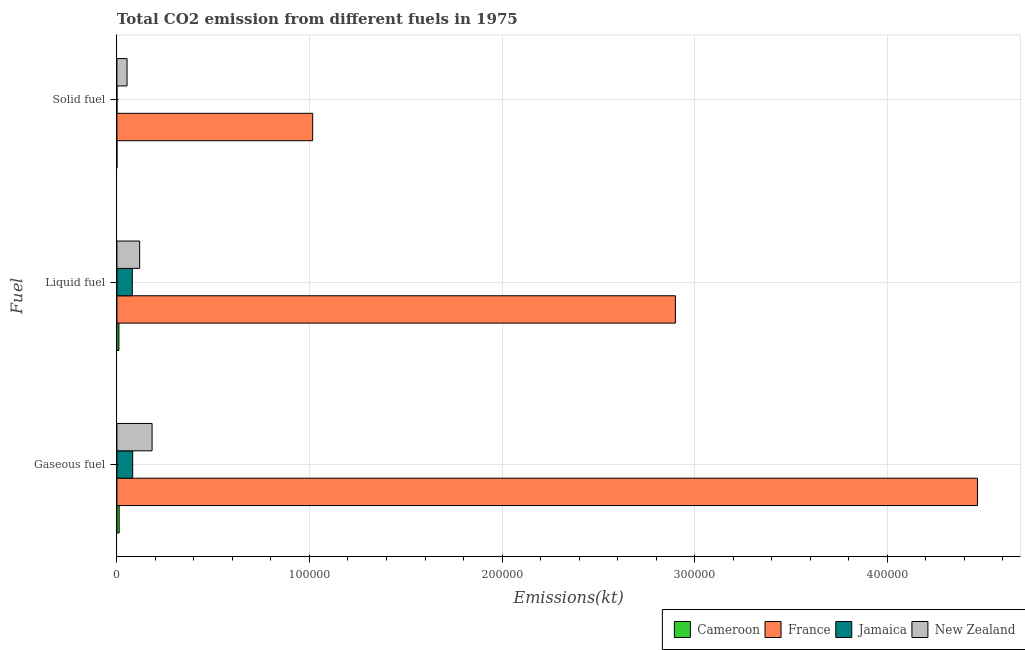How many different coloured bars are there?
Ensure brevity in your answer.  4. Are the number of bars per tick equal to the number of legend labels?
Make the answer very short. Yes. What is the label of the 1st group of bars from the top?
Keep it short and to the point. Solid fuel. What is the amount of co2 emissions from liquid fuel in Cameroon?
Offer a very short reply. 1041.43. Across all countries, what is the maximum amount of co2 emissions from liquid fuel?
Ensure brevity in your answer.  2.90e+05. Across all countries, what is the minimum amount of co2 emissions from solid fuel?
Keep it short and to the point. 3.67. In which country was the amount of co2 emissions from liquid fuel maximum?
Your answer should be compact. France. In which country was the amount of co2 emissions from solid fuel minimum?
Provide a succinct answer. Cameroon. What is the total amount of co2 emissions from liquid fuel in the graph?
Your answer should be very brief. 3.11e+05. What is the difference between the amount of co2 emissions from liquid fuel in Cameroon and that in France?
Keep it short and to the point. -2.89e+05. What is the difference between the amount of co2 emissions from gaseous fuel in Cameroon and the amount of co2 emissions from solid fuel in New Zealand?
Your answer should be very brief. -4092.37. What is the average amount of co2 emissions from gaseous fuel per country?
Offer a very short reply. 1.19e+05. What is the difference between the amount of co2 emissions from solid fuel and amount of co2 emissions from gaseous fuel in New Zealand?
Ensure brevity in your answer.  -1.30e+04. What is the ratio of the amount of co2 emissions from solid fuel in France to that in New Zealand?
Ensure brevity in your answer.  19.35. What is the difference between the highest and the second highest amount of co2 emissions from liquid fuel?
Provide a succinct answer. 2.78e+05. What is the difference between the highest and the lowest amount of co2 emissions from liquid fuel?
Give a very brief answer. 2.89e+05. In how many countries, is the amount of co2 emissions from gaseous fuel greater than the average amount of co2 emissions from gaseous fuel taken over all countries?
Your answer should be very brief. 1. Is the sum of the amount of co2 emissions from gaseous fuel in Cameroon and Jamaica greater than the maximum amount of co2 emissions from solid fuel across all countries?
Give a very brief answer. No. What does the 4th bar from the top in Liquid fuel represents?
Offer a terse response. Cameroon. What does the 4th bar from the bottom in Liquid fuel represents?
Your response must be concise. New Zealand. Are all the bars in the graph horizontal?
Ensure brevity in your answer.  Yes. How many countries are there in the graph?
Give a very brief answer. 4. Are the values on the major ticks of X-axis written in scientific E-notation?
Make the answer very short. No. Does the graph contain any zero values?
Give a very brief answer. No. Where does the legend appear in the graph?
Offer a terse response. Bottom right. How many legend labels are there?
Provide a short and direct response. 4. How are the legend labels stacked?
Your answer should be very brief. Horizontal. What is the title of the graph?
Make the answer very short. Total CO2 emission from different fuels in 1975. Does "United Kingdom" appear as one of the legend labels in the graph?
Your answer should be compact. No. What is the label or title of the X-axis?
Provide a short and direct response. Emissions(kt). What is the label or title of the Y-axis?
Ensure brevity in your answer.  Fuel. What is the Emissions(kt) in Cameroon in Gaseous fuel?
Provide a short and direct response. 1162.44. What is the Emissions(kt) of France in Gaseous fuel?
Ensure brevity in your answer.  4.47e+05. What is the Emissions(kt) of Jamaica in Gaseous fuel?
Keep it short and to the point. 8188.41. What is the Emissions(kt) of New Zealand in Gaseous fuel?
Offer a very short reply. 1.83e+04. What is the Emissions(kt) in Cameroon in Liquid fuel?
Keep it short and to the point. 1041.43. What is the Emissions(kt) of France in Liquid fuel?
Provide a succinct answer. 2.90e+05. What is the Emissions(kt) in Jamaica in Liquid fuel?
Provide a succinct answer. 7983.06. What is the Emissions(kt) in New Zealand in Liquid fuel?
Your answer should be very brief. 1.18e+04. What is the Emissions(kt) of Cameroon in Solid fuel?
Your answer should be very brief. 3.67. What is the Emissions(kt) of France in Solid fuel?
Offer a terse response. 1.02e+05. What is the Emissions(kt) of Jamaica in Solid fuel?
Make the answer very short. 3.67. What is the Emissions(kt) of New Zealand in Solid fuel?
Your answer should be very brief. 5254.81. Across all Fuel, what is the maximum Emissions(kt) of Cameroon?
Provide a succinct answer. 1162.44. Across all Fuel, what is the maximum Emissions(kt) in France?
Ensure brevity in your answer.  4.47e+05. Across all Fuel, what is the maximum Emissions(kt) of Jamaica?
Offer a terse response. 8188.41. Across all Fuel, what is the maximum Emissions(kt) of New Zealand?
Provide a short and direct response. 1.83e+04. Across all Fuel, what is the minimum Emissions(kt) of Cameroon?
Make the answer very short. 3.67. Across all Fuel, what is the minimum Emissions(kt) of France?
Offer a terse response. 1.02e+05. Across all Fuel, what is the minimum Emissions(kt) in Jamaica?
Offer a very short reply. 3.67. Across all Fuel, what is the minimum Emissions(kt) in New Zealand?
Your answer should be compact. 5254.81. What is the total Emissions(kt) in Cameroon in the graph?
Your answer should be very brief. 2207.53. What is the total Emissions(kt) of France in the graph?
Keep it short and to the point. 8.39e+05. What is the total Emissions(kt) in Jamaica in the graph?
Provide a short and direct response. 1.62e+04. What is the total Emissions(kt) in New Zealand in the graph?
Ensure brevity in your answer.  3.53e+04. What is the difference between the Emissions(kt) of Cameroon in Gaseous fuel and that in Liquid fuel?
Your response must be concise. 121.01. What is the difference between the Emissions(kt) in France in Gaseous fuel and that in Liquid fuel?
Keep it short and to the point. 1.57e+05. What is the difference between the Emissions(kt) in Jamaica in Gaseous fuel and that in Liquid fuel?
Your response must be concise. 205.35. What is the difference between the Emissions(kt) of New Zealand in Gaseous fuel and that in Liquid fuel?
Offer a terse response. 6461.25. What is the difference between the Emissions(kt) in Cameroon in Gaseous fuel and that in Solid fuel?
Your response must be concise. 1158.77. What is the difference between the Emissions(kt) in France in Gaseous fuel and that in Solid fuel?
Keep it short and to the point. 3.45e+05. What is the difference between the Emissions(kt) in Jamaica in Gaseous fuel and that in Solid fuel?
Offer a terse response. 8184.74. What is the difference between the Emissions(kt) of New Zealand in Gaseous fuel and that in Solid fuel?
Your response must be concise. 1.30e+04. What is the difference between the Emissions(kt) of Cameroon in Liquid fuel and that in Solid fuel?
Your response must be concise. 1037.76. What is the difference between the Emissions(kt) of France in Liquid fuel and that in Solid fuel?
Your response must be concise. 1.88e+05. What is the difference between the Emissions(kt) in Jamaica in Liquid fuel and that in Solid fuel?
Provide a succinct answer. 7979.39. What is the difference between the Emissions(kt) of New Zealand in Liquid fuel and that in Solid fuel?
Give a very brief answer. 6545.6. What is the difference between the Emissions(kt) of Cameroon in Gaseous fuel and the Emissions(kt) of France in Liquid fuel?
Provide a succinct answer. -2.89e+05. What is the difference between the Emissions(kt) in Cameroon in Gaseous fuel and the Emissions(kt) in Jamaica in Liquid fuel?
Provide a short and direct response. -6820.62. What is the difference between the Emissions(kt) of Cameroon in Gaseous fuel and the Emissions(kt) of New Zealand in Liquid fuel?
Ensure brevity in your answer.  -1.06e+04. What is the difference between the Emissions(kt) in France in Gaseous fuel and the Emissions(kt) in Jamaica in Liquid fuel?
Provide a succinct answer. 4.39e+05. What is the difference between the Emissions(kt) of France in Gaseous fuel and the Emissions(kt) of New Zealand in Liquid fuel?
Your answer should be very brief. 4.35e+05. What is the difference between the Emissions(kt) of Jamaica in Gaseous fuel and the Emissions(kt) of New Zealand in Liquid fuel?
Provide a short and direct response. -3611.99. What is the difference between the Emissions(kt) of Cameroon in Gaseous fuel and the Emissions(kt) of France in Solid fuel?
Give a very brief answer. -1.01e+05. What is the difference between the Emissions(kt) in Cameroon in Gaseous fuel and the Emissions(kt) in Jamaica in Solid fuel?
Make the answer very short. 1158.77. What is the difference between the Emissions(kt) in Cameroon in Gaseous fuel and the Emissions(kt) in New Zealand in Solid fuel?
Ensure brevity in your answer.  -4092.37. What is the difference between the Emissions(kt) in France in Gaseous fuel and the Emissions(kt) in Jamaica in Solid fuel?
Ensure brevity in your answer.  4.47e+05. What is the difference between the Emissions(kt) of France in Gaseous fuel and the Emissions(kt) of New Zealand in Solid fuel?
Provide a succinct answer. 4.42e+05. What is the difference between the Emissions(kt) of Jamaica in Gaseous fuel and the Emissions(kt) of New Zealand in Solid fuel?
Your answer should be very brief. 2933.6. What is the difference between the Emissions(kt) of Cameroon in Liquid fuel and the Emissions(kt) of France in Solid fuel?
Your answer should be compact. -1.01e+05. What is the difference between the Emissions(kt) in Cameroon in Liquid fuel and the Emissions(kt) in Jamaica in Solid fuel?
Provide a short and direct response. 1037.76. What is the difference between the Emissions(kt) of Cameroon in Liquid fuel and the Emissions(kt) of New Zealand in Solid fuel?
Your answer should be compact. -4213.38. What is the difference between the Emissions(kt) in France in Liquid fuel and the Emissions(kt) in Jamaica in Solid fuel?
Make the answer very short. 2.90e+05. What is the difference between the Emissions(kt) in France in Liquid fuel and the Emissions(kt) in New Zealand in Solid fuel?
Offer a terse response. 2.85e+05. What is the difference between the Emissions(kt) in Jamaica in Liquid fuel and the Emissions(kt) in New Zealand in Solid fuel?
Your answer should be very brief. 2728.25. What is the average Emissions(kt) of Cameroon per Fuel?
Give a very brief answer. 735.84. What is the average Emissions(kt) of France per Fuel?
Your answer should be compact. 2.80e+05. What is the average Emissions(kt) of Jamaica per Fuel?
Your response must be concise. 5391.71. What is the average Emissions(kt) in New Zealand per Fuel?
Give a very brief answer. 1.18e+04. What is the difference between the Emissions(kt) in Cameroon and Emissions(kt) in France in Gaseous fuel?
Ensure brevity in your answer.  -4.46e+05. What is the difference between the Emissions(kt) in Cameroon and Emissions(kt) in Jamaica in Gaseous fuel?
Provide a succinct answer. -7025.97. What is the difference between the Emissions(kt) in Cameroon and Emissions(kt) in New Zealand in Gaseous fuel?
Your response must be concise. -1.71e+04. What is the difference between the Emissions(kt) of France and Emissions(kt) of Jamaica in Gaseous fuel?
Your response must be concise. 4.39e+05. What is the difference between the Emissions(kt) in France and Emissions(kt) in New Zealand in Gaseous fuel?
Your response must be concise. 4.29e+05. What is the difference between the Emissions(kt) in Jamaica and Emissions(kt) in New Zealand in Gaseous fuel?
Provide a succinct answer. -1.01e+04. What is the difference between the Emissions(kt) in Cameroon and Emissions(kt) in France in Liquid fuel?
Ensure brevity in your answer.  -2.89e+05. What is the difference between the Emissions(kt) in Cameroon and Emissions(kt) in Jamaica in Liquid fuel?
Keep it short and to the point. -6941.63. What is the difference between the Emissions(kt) of Cameroon and Emissions(kt) of New Zealand in Liquid fuel?
Your response must be concise. -1.08e+04. What is the difference between the Emissions(kt) in France and Emissions(kt) in Jamaica in Liquid fuel?
Your response must be concise. 2.82e+05. What is the difference between the Emissions(kt) in France and Emissions(kt) in New Zealand in Liquid fuel?
Offer a terse response. 2.78e+05. What is the difference between the Emissions(kt) in Jamaica and Emissions(kt) in New Zealand in Liquid fuel?
Your answer should be very brief. -3817.35. What is the difference between the Emissions(kt) in Cameroon and Emissions(kt) in France in Solid fuel?
Offer a terse response. -1.02e+05. What is the difference between the Emissions(kt) in Cameroon and Emissions(kt) in New Zealand in Solid fuel?
Your answer should be compact. -5251.14. What is the difference between the Emissions(kt) of France and Emissions(kt) of Jamaica in Solid fuel?
Your answer should be very brief. 1.02e+05. What is the difference between the Emissions(kt) of France and Emissions(kt) of New Zealand in Solid fuel?
Your answer should be very brief. 9.64e+04. What is the difference between the Emissions(kt) in Jamaica and Emissions(kt) in New Zealand in Solid fuel?
Keep it short and to the point. -5251.14. What is the ratio of the Emissions(kt) in Cameroon in Gaseous fuel to that in Liquid fuel?
Keep it short and to the point. 1.12. What is the ratio of the Emissions(kt) of France in Gaseous fuel to that in Liquid fuel?
Offer a terse response. 1.54. What is the ratio of the Emissions(kt) of Jamaica in Gaseous fuel to that in Liquid fuel?
Ensure brevity in your answer.  1.03. What is the ratio of the Emissions(kt) of New Zealand in Gaseous fuel to that in Liquid fuel?
Your answer should be very brief. 1.55. What is the ratio of the Emissions(kt) in Cameroon in Gaseous fuel to that in Solid fuel?
Offer a terse response. 317. What is the ratio of the Emissions(kt) in France in Gaseous fuel to that in Solid fuel?
Ensure brevity in your answer.  4.4. What is the ratio of the Emissions(kt) in Jamaica in Gaseous fuel to that in Solid fuel?
Provide a succinct answer. 2233. What is the ratio of the Emissions(kt) of New Zealand in Gaseous fuel to that in Solid fuel?
Ensure brevity in your answer.  3.48. What is the ratio of the Emissions(kt) in Cameroon in Liquid fuel to that in Solid fuel?
Make the answer very short. 284. What is the ratio of the Emissions(kt) in France in Liquid fuel to that in Solid fuel?
Your answer should be compact. 2.85. What is the ratio of the Emissions(kt) in Jamaica in Liquid fuel to that in Solid fuel?
Make the answer very short. 2177. What is the ratio of the Emissions(kt) in New Zealand in Liquid fuel to that in Solid fuel?
Make the answer very short. 2.25. What is the difference between the highest and the second highest Emissions(kt) of Cameroon?
Provide a succinct answer. 121.01. What is the difference between the highest and the second highest Emissions(kt) in France?
Your answer should be very brief. 1.57e+05. What is the difference between the highest and the second highest Emissions(kt) in Jamaica?
Make the answer very short. 205.35. What is the difference between the highest and the second highest Emissions(kt) of New Zealand?
Your response must be concise. 6461.25. What is the difference between the highest and the lowest Emissions(kt) in Cameroon?
Keep it short and to the point. 1158.77. What is the difference between the highest and the lowest Emissions(kt) in France?
Keep it short and to the point. 3.45e+05. What is the difference between the highest and the lowest Emissions(kt) in Jamaica?
Your answer should be very brief. 8184.74. What is the difference between the highest and the lowest Emissions(kt) in New Zealand?
Make the answer very short. 1.30e+04. 